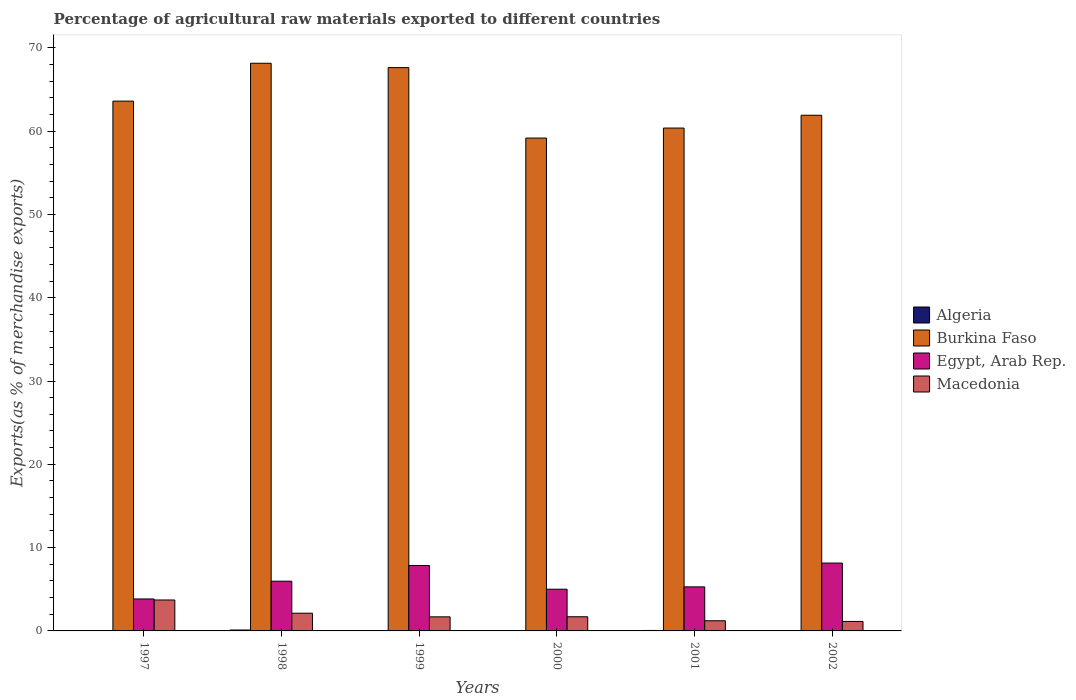How many different coloured bars are there?
Ensure brevity in your answer.  4. Are the number of bars per tick equal to the number of legend labels?
Provide a short and direct response. Yes. Are the number of bars on each tick of the X-axis equal?
Provide a short and direct response. Yes. How many bars are there on the 4th tick from the left?
Your answer should be compact. 4. How many bars are there on the 3rd tick from the right?
Make the answer very short. 4. What is the label of the 5th group of bars from the left?
Offer a very short reply. 2001. What is the percentage of exports to different countries in Macedonia in 2002?
Ensure brevity in your answer.  1.14. Across all years, what is the maximum percentage of exports to different countries in Burkina Faso?
Your answer should be very brief. 68.14. Across all years, what is the minimum percentage of exports to different countries in Macedonia?
Your answer should be compact. 1.14. In which year was the percentage of exports to different countries in Egypt, Arab Rep. maximum?
Your response must be concise. 2002. What is the total percentage of exports to different countries in Burkina Faso in the graph?
Give a very brief answer. 380.79. What is the difference between the percentage of exports to different countries in Egypt, Arab Rep. in 1998 and that in 2001?
Give a very brief answer. 0.68. What is the difference between the percentage of exports to different countries in Egypt, Arab Rep. in 2000 and the percentage of exports to different countries in Macedonia in 1997?
Give a very brief answer. 1.29. What is the average percentage of exports to different countries in Burkina Faso per year?
Offer a very short reply. 63.47. In the year 1999, what is the difference between the percentage of exports to different countries in Macedonia and percentage of exports to different countries in Burkina Faso?
Keep it short and to the point. -65.93. What is the ratio of the percentage of exports to different countries in Algeria in 1997 to that in 2002?
Make the answer very short. 3.18. What is the difference between the highest and the second highest percentage of exports to different countries in Burkina Faso?
Your answer should be very brief. 0.52. What is the difference between the highest and the lowest percentage of exports to different countries in Macedonia?
Ensure brevity in your answer.  2.58. Is it the case that in every year, the sum of the percentage of exports to different countries in Egypt, Arab Rep. and percentage of exports to different countries in Macedonia is greater than the sum of percentage of exports to different countries in Burkina Faso and percentage of exports to different countries in Algeria?
Offer a terse response. No. What does the 3rd bar from the left in 2001 represents?
Give a very brief answer. Egypt, Arab Rep. What does the 3rd bar from the right in 1998 represents?
Your answer should be compact. Burkina Faso. How many bars are there?
Make the answer very short. 24. Are all the bars in the graph horizontal?
Offer a terse response. No. What is the difference between two consecutive major ticks on the Y-axis?
Provide a succinct answer. 10. Does the graph contain grids?
Make the answer very short. No. How many legend labels are there?
Your response must be concise. 4. How are the legend labels stacked?
Give a very brief answer. Vertical. What is the title of the graph?
Provide a succinct answer. Percentage of agricultural raw materials exported to different countries. Does "Jamaica" appear as one of the legend labels in the graph?
Offer a very short reply. No. What is the label or title of the Y-axis?
Make the answer very short. Exports(as % of merchandise exports). What is the Exports(as % of merchandise exports) of Algeria in 1997?
Ensure brevity in your answer.  0.05. What is the Exports(as % of merchandise exports) of Burkina Faso in 1997?
Your answer should be compact. 63.6. What is the Exports(as % of merchandise exports) in Egypt, Arab Rep. in 1997?
Your response must be concise. 3.84. What is the Exports(as % of merchandise exports) in Macedonia in 1997?
Make the answer very short. 3.71. What is the Exports(as % of merchandise exports) of Algeria in 1998?
Your answer should be compact. 0.11. What is the Exports(as % of merchandise exports) in Burkina Faso in 1998?
Offer a terse response. 68.14. What is the Exports(as % of merchandise exports) of Egypt, Arab Rep. in 1998?
Make the answer very short. 5.97. What is the Exports(as % of merchandise exports) of Macedonia in 1998?
Keep it short and to the point. 2.13. What is the Exports(as % of merchandise exports) of Algeria in 1999?
Keep it short and to the point. 0.04. What is the Exports(as % of merchandise exports) in Burkina Faso in 1999?
Offer a terse response. 67.62. What is the Exports(as % of merchandise exports) of Egypt, Arab Rep. in 1999?
Your answer should be compact. 7.85. What is the Exports(as % of merchandise exports) of Macedonia in 1999?
Your answer should be compact. 1.69. What is the Exports(as % of merchandise exports) in Algeria in 2000?
Ensure brevity in your answer.  0.05. What is the Exports(as % of merchandise exports) in Burkina Faso in 2000?
Your answer should be compact. 59.16. What is the Exports(as % of merchandise exports) in Egypt, Arab Rep. in 2000?
Your answer should be compact. 5.01. What is the Exports(as % of merchandise exports) in Macedonia in 2000?
Make the answer very short. 1.7. What is the Exports(as % of merchandise exports) in Algeria in 2001?
Your answer should be very brief. 0.05. What is the Exports(as % of merchandise exports) of Burkina Faso in 2001?
Give a very brief answer. 60.36. What is the Exports(as % of merchandise exports) of Egypt, Arab Rep. in 2001?
Ensure brevity in your answer.  5.29. What is the Exports(as % of merchandise exports) in Macedonia in 2001?
Provide a short and direct response. 1.22. What is the Exports(as % of merchandise exports) in Algeria in 2002?
Your response must be concise. 0.02. What is the Exports(as % of merchandise exports) in Burkina Faso in 2002?
Keep it short and to the point. 61.9. What is the Exports(as % of merchandise exports) of Egypt, Arab Rep. in 2002?
Provide a short and direct response. 8.15. What is the Exports(as % of merchandise exports) in Macedonia in 2002?
Give a very brief answer. 1.14. Across all years, what is the maximum Exports(as % of merchandise exports) of Algeria?
Your answer should be very brief. 0.11. Across all years, what is the maximum Exports(as % of merchandise exports) of Burkina Faso?
Provide a succinct answer. 68.14. Across all years, what is the maximum Exports(as % of merchandise exports) of Egypt, Arab Rep.?
Your answer should be compact. 8.15. Across all years, what is the maximum Exports(as % of merchandise exports) of Macedonia?
Offer a very short reply. 3.71. Across all years, what is the minimum Exports(as % of merchandise exports) in Algeria?
Your response must be concise. 0.02. Across all years, what is the minimum Exports(as % of merchandise exports) of Burkina Faso?
Your response must be concise. 59.16. Across all years, what is the minimum Exports(as % of merchandise exports) of Egypt, Arab Rep.?
Keep it short and to the point. 3.84. Across all years, what is the minimum Exports(as % of merchandise exports) of Macedonia?
Give a very brief answer. 1.14. What is the total Exports(as % of merchandise exports) in Algeria in the graph?
Keep it short and to the point. 0.32. What is the total Exports(as % of merchandise exports) in Burkina Faso in the graph?
Your answer should be compact. 380.79. What is the total Exports(as % of merchandise exports) in Egypt, Arab Rep. in the graph?
Your answer should be compact. 36.1. What is the total Exports(as % of merchandise exports) of Macedonia in the graph?
Your answer should be compact. 11.59. What is the difference between the Exports(as % of merchandise exports) of Algeria in 1997 and that in 1998?
Keep it short and to the point. -0.06. What is the difference between the Exports(as % of merchandise exports) in Burkina Faso in 1997 and that in 1998?
Ensure brevity in your answer.  -4.54. What is the difference between the Exports(as % of merchandise exports) in Egypt, Arab Rep. in 1997 and that in 1998?
Offer a very short reply. -2.13. What is the difference between the Exports(as % of merchandise exports) of Macedonia in 1997 and that in 1998?
Provide a succinct answer. 1.59. What is the difference between the Exports(as % of merchandise exports) in Algeria in 1997 and that in 1999?
Keep it short and to the point. 0.01. What is the difference between the Exports(as % of merchandise exports) of Burkina Faso in 1997 and that in 1999?
Your response must be concise. -4.02. What is the difference between the Exports(as % of merchandise exports) in Egypt, Arab Rep. in 1997 and that in 1999?
Make the answer very short. -4.02. What is the difference between the Exports(as % of merchandise exports) of Macedonia in 1997 and that in 1999?
Provide a short and direct response. 2.02. What is the difference between the Exports(as % of merchandise exports) of Algeria in 1997 and that in 2000?
Make the answer very short. -0. What is the difference between the Exports(as % of merchandise exports) in Burkina Faso in 1997 and that in 2000?
Your answer should be compact. 4.44. What is the difference between the Exports(as % of merchandise exports) in Egypt, Arab Rep. in 1997 and that in 2000?
Ensure brevity in your answer.  -1.17. What is the difference between the Exports(as % of merchandise exports) of Macedonia in 1997 and that in 2000?
Provide a succinct answer. 2.01. What is the difference between the Exports(as % of merchandise exports) of Algeria in 1997 and that in 2001?
Provide a succinct answer. -0.01. What is the difference between the Exports(as % of merchandise exports) in Burkina Faso in 1997 and that in 2001?
Keep it short and to the point. 3.23. What is the difference between the Exports(as % of merchandise exports) in Egypt, Arab Rep. in 1997 and that in 2001?
Give a very brief answer. -1.45. What is the difference between the Exports(as % of merchandise exports) in Macedonia in 1997 and that in 2001?
Provide a succinct answer. 2.49. What is the difference between the Exports(as % of merchandise exports) in Algeria in 1997 and that in 2002?
Give a very brief answer. 0.03. What is the difference between the Exports(as % of merchandise exports) in Burkina Faso in 1997 and that in 2002?
Make the answer very short. 1.7. What is the difference between the Exports(as % of merchandise exports) of Egypt, Arab Rep. in 1997 and that in 2002?
Keep it short and to the point. -4.31. What is the difference between the Exports(as % of merchandise exports) in Macedonia in 1997 and that in 2002?
Give a very brief answer. 2.58. What is the difference between the Exports(as % of merchandise exports) of Algeria in 1998 and that in 1999?
Offer a terse response. 0.07. What is the difference between the Exports(as % of merchandise exports) in Burkina Faso in 1998 and that in 1999?
Your answer should be compact. 0.52. What is the difference between the Exports(as % of merchandise exports) in Egypt, Arab Rep. in 1998 and that in 1999?
Your answer should be very brief. -1.88. What is the difference between the Exports(as % of merchandise exports) in Macedonia in 1998 and that in 1999?
Give a very brief answer. 0.44. What is the difference between the Exports(as % of merchandise exports) of Algeria in 1998 and that in 2000?
Provide a succinct answer. 0.06. What is the difference between the Exports(as % of merchandise exports) of Burkina Faso in 1998 and that in 2000?
Give a very brief answer. 8.98. What is the difference between the Exports(as % of merchandise exports) in Egypt, Arab Rep. in 1998 and that in 2000?
Provide a short and direct response. 0.96. What is the difference between the Exports(as % of merchandise exports) of Macedonia in 1998 and that in 2000?
Give a very brief answer. 0.43. What is the difference between the Exports(as % of merchandise exports) of Algeria in 1998 and that in 2001?
Your answer should be very brief. 0.05. What is the difference between the Exports(as % of merchandise exports) of Burkina Faso in 1998 and that in 2001?
Your response must be concise. 7.78. What is the difference between the Exports(as % of merchandise exports) in Egypt, Arab Rep. in 1998 and that in 2001?
Make the answer very short. 0.68. What is the difference between the Exports(as % of merchandise exports) in Macedonia in 1998 and that in 2001?
Your answer should be compact. 0.91. What is the difference between the Exports(as % of merchandise exports) in Algeria in 1998 and that in 2002?
Provide a succinct answer. 0.09. What is the difference between the Exports(as % of merchandise exports) of Burkina Faso in 1998 and that in 2002?
Provide a succinct answer. 6.24. What is the difference between the Exports(as % of merchandise exports) in Egypt, Arab Rep. in 1998 and that in 2002?
Your response must be concise. -2.18. What is the difference between the Exports(as % of merchandise exports) in Algeria in 1999 and that in 2000?
Make the answer very short. -0.01. What is the difference between the Exports(as % of merchandise exports) of Burkina Faso in 1999 and that in 2000?
Your response must be concise. 8.46. What is the difference between the Exports(as % of merchandise exports) of Egypt, Arab Rep. in 1999 and that in 2000?
Provide a short and direct response. 2.85. What is the difference between the Exports(as % of merchandise exports) in Macedonia in 1999 and that in 2000?
Give a very brief answer. -0.01. What is the difference between the Exports(as % of merchandise exports) of Algeria in 1999 and that in 2001?
Make the answer very short. -0.02. What is the difference between the Exports(as % of merchandise exports) of Burkina Faso in 1999 and that in 2001?
Provide a succinct answer. 7.26. What is the difference between the Exports(as % of merchandise exports) in Egypt, Arab Rep. in 1999 and that in 2001?
Keep it short and to the point. 2.57. What is the difference between the Exports(as % of merchandise exports) in Macedonia in 1999 and that in 2001?
Your response must be concise. 0.47. What is the difference between the Exports(as % of merchandise exports) in Algeria in 1999 and that in 2002?
Give a very brief answer. 0.02. What is the difference between the Exports(as % of merchandise exports) in Burkina Faso in 1999 and that in 2002?
Make the answer very short. 5.72. What is the difference between the Exports(as % of merchandise exports) of Egypt, Arab Rep. in 1999 and that in 2002?
Your answer should be compact. -0.29. What is the difference between the Exports(as % of merchandise exports) of Macedonia in 1999 and that in 2002?
Your answer should be very brief. 0.55. What is the difference between the Exports(as % of merchandise exports) of Algeria in 2000 and that in 2001?
Keep it short and to the point. -0.01. What is the difference between the Exports(as % of merchandise exports) in Burkina Faso in 2000 and that in 2001?
Provide a succinct answer. -1.2. What is the difference between the Exports(as % of merchandise exports) in Egypt, Arab Rep. in 2000 and that in 2001?
Your answer should be compact. -0.28. What is the difference between the Exports(as % of merchandise exports) in Macedonia in 2000 and that in 2001?
Offer a very short reply. 0.48. What is the difference between the Exports(as % of merchandise exports) in Algeria in 2000 and that in 2002?
Make the answer very short. 0.03. What is the difference between the Exports(as % of merchandise exports) of Burkina Faso in 2000 and that in 2002?
Offer a very short reply. -2.74. What is the difference between the Exports(as % of merchandise exports) of Egypt, Arab Rep. in 2000 and that in 2002?
Provide a short and direct response. -3.14. What is the difference between the Exports(as % of merchandise exports) in Macedonia in 2000 and that in 2002?
Your response must be concise. 0.56. What is the difference between the Exports(as % of merchandise exports) in Algeria in 2001 and that in 2002?
Make the answer very short. 0.04. What is the difference between the Exports(as % of merchandise exports) of Burkina Faso in 2001 and that in 2002?
Ensure brevity in your answer.  -1.54. What is the difference between the Exports(as % of merchandise exports) in Egypt, Arab Rep. in 2001 and that in 2002?
Ensure brevity in your answer.  -2.86. What is the difference between the Exports(as % of merchandise exports) of Macedonia in 2001 and that in 2002?
Provide a short and direct response. 0.08. What is the difference between the Exports(as % of merchandise exports) of Algeria in 1997 and the Exports(as % of merchandise exports) of Burkina Faso in 1998?
Offer a terse response. -68.09. What is the difference between the Exports(as % of merchandise exports) in Algeria in 1997 and the Exports(as % of merchandise exports) in Egypt, Arab Rep. in 1998?
Your answer should be compact. -5.92. What is the difference between the Exports(as % of merchandise exports) of Algeria in 1997 and the Exports(as % of merchandise exports) of Macedonia in 1998?
Keep it short and to the point. -2.08. What is the difference between the Exports(as % of merchandise exports) of Burkina Faso in 1997 and the Exports(as % of merchandise exports) of Egypt, Arab Rep. in 1998?
Your answer should be compact. 57.63. What is the difference between the Exports(as % of merchandise exports) in Burkina Faso in 1997 and the Exports(as % of merchandise exports) in Macedonia in 1998?
Your answer should be compact. 61.47. What is the difference between the Exports(as % of merchandise exports) in Egypt, Arab Rep. in 1997 and the Exports(as % of merchandise exports) in Macedonia in 1998?
Offer a very short reply. 1.71. What is the difference between the Exports(as % of merchandise exports) of Algeria in 1997 and the Exports(as % of merchandise exports) of Burkina Faso in 1999?
Offer a very short reply. -67.57. What is the difference between the Exports(as % of merchandise exports) in Algeria in 1997 and the Exports(as % of merchandise exports) in Egypt, Arab Rep. in 1999?
Offer a terse response. -7.8. What is the difference between the Exports(as % of merchandise exports) of Algeria in 1997 and the Exports(as % of merchandise exports) of Macedonia in 1999?
Your answer should be compact. -1.64. What is the difference between the Exports(as % of merchandise exports) in Burkina Faso in 1997 and the Exports(as % of merchandise exports) in Egypt, Arab Rep. in 1999?
Ensure brevity in your answer.  55.74. What is the difference between the Exports(as % of merchandise exports) of Burkina Faso in 1997 and the Exports(as % of merchandise exports) of Macedonia in 1999?
Make the answer very short. 61.91. What is the difference between the Exports(as % of merchandise exports) in Egypt, Arab Rep. in 1997 and the Exports(as % of merchandise exports) in Macedonia in 1999?
Your answer should be compact. 2.15. What is the difference between the Exports(as % of merchandise exports) of Algeria in 1997 and the Exports(as % of merchandise exports) of Burkina Faso in 2000?
Your answer should be compact. -59.11. What is the difference between the Exports(as % of merchandise exports) in Algeria in 1997 and the Exports(as % of merchandise exports) in Egypt, Arab Rep. in 2000?
Keep it short and to the point. -4.96. What is the difference between the Exports(as % of merchandise exports) of Algeria in 1997 and the Exports(as % of merchandise exports) of Macedonia in 2000?
Your response must be concise. -1.65. What is the difference between the Exports(as % of merchandise exports) in Burkina Faso in 1997 and the Exports(as % of merchandise exports) in Egypt, Arab Rep. in 2000?
Offer a terse response. 58.59. What is the difference between the Exports(as % of merchandise exports) in Burkina Faso in 1997 and the Exports(as % of merchandise exports) in Macedonia in 2000?
Provide a short and direct response. 61.9. What is the difference between the Exports(as % of merchandise exports) of Egypt, Arab Rep. in 1997 and the Exports(as % of merchandise exports) of Macedonia in 2000?
Make the answer very short. 2.14. What is the difference between the Exports(as % of merchandise exports) in Algeria in 1997 and the Exports(as % of merchandise exports) in Burkina Faso in 2001?
Ensure brevity in your answer.  -60.31. What is the difference between the Exports(as % of merchandise exports) of Algeria in 1997 and the Exports(as % of merchandise exports) of Egypt, Arab Rep. in 2001?
Offer a terse response. -5.24. What is the difference between the Exports(as % of merchandise exports) in Algeria in 1997 and the Exports(as % of merchandise exports) in Macedonia in 2001?
Provide a short and direct response. -1.17. What is the difference between the Exports(as % of merchandise exports) of Burkina Faso in 1997 and the Exports(as % of merchandise exports) of Egypt, Arab Rep. in 2001?
Ensure brevity in your answer.  58.31. What is the difference between the Exports(as % of merchandise exports) of Burkina Faso in 1997 and the Exports(as % of merchandise exports) of Macedonia in 2001?
Your response must be concise. 62.38. What is the difference between the Exports(as % of merchandise exports) in Egypt, Arab Rep. in 1997 and the Exports(as % of merchandise exports) in Macedonia in 2001?
Offer a very short reply. 2.62. What is the difference between the Exports(as % of merchandise exports) in Algeria in 1997 and the Exports(as % of merchandise exports) in Burkina Faso in 2002?
Offer a terse response. -61.85. What is the difference between the Exports(as % of merchandise exports) of Algeria in 1997 and the Exports(as % of merchandise exports) of Egypt, Arab Rep. in 2002?
Give a very brief answer. -8.1. What is the difference between the Exports(as % of merchandise exports) in Algeria in 1997 and the Exports(as % of merchandise exports) in Macedonia in 2002?
Your response must be concise. -1.09. What is the difference between the Exports(as % of merchandise exports) of Burkina Faso in 1997 and the Exports(as % of merchandise exports) of Egypt, Arab Rep. in 2002?
Provide a succinct answer. 55.45. What is the difference between the Exports(as % of merchandise exports) in Burkina Faso in 1997 and the Exports(as % of merchandise exports) in Macedonia in 2002?
Your response must be concise. 62.46. What is the difference between the Exports(as % of merchandise exports) in Egypt, Arab Rep. in 1997 and the Exports(as % of merchandise exports) in Macedonia in 2002?
Give a very brief answer. 2.7. What is the difference between the Exports(as % of merchandise exports) in Algeria in 1998 and the Exports(as % of merchandise exports) in Burkina Faso in 1999?
Keep it short and to the point. -67.51. What is the difference between the Exports(as % of merchandise exports) of Algeria in 1998 and the Exports(as % of merchandise exports) of Egypt, Arab Rep. in 1999?
Your response must be concise. -7.74. What is the difference between the Exports(as % of merchandise exports) of Algeria in 1998 and the Exports(as % of merchandise exports) of Macedonia in 1999?
Provide a short and direct response. -1.58. What is the difference between the Exports(as % of merchandise exports) in Burkina Faso in 1998 and the Exports(as % of merchandise exports) in Egypt, Arab Rep. in 1999?
Ensure brevity in your answer.  60.29. What is the difference between the Exports(as % of merchandise exports) of Burkina Faso in 1998 and the Exports(as % of merchandise exports) of Macedonia in 1999?
Offer a terse response. 66.45. What is the difference between the Exports(as % of merchandise exports) of Egypt, Arab Rep. in 1998 and the Exports(as % of merchandise exports) of Macedonia in 1999?
Provide a short and direct response. 4.28. What is the difference between the Exports(as % of merchandise exports) in Algeria in 1998 and the Exports(as % of merchandise exports) in Burkina Faso in 2000?
Give a very brief answer. -59.05. What is the difference between the Exports(as % of merchandise exports) of Algeria in 1998 and the Exports(as % of merchandise exports) of Egypt, Arab Rep. in 2000?
Your response must be concise. -4.9. What is the difference between the Exports(as % of merchandise exports) in Algeria in 1998 and the Exports(as % of merchandise exports) in Macedonia in 2000?
Offer a very short reply. -1.59. What is the difference between the Exports(as % of merchandise exports) in Burkina Faso in 1998 and the Exports(as % of merchandise exports) in Egypt, Arab Rep. in 2000?
Make the answer very short. 63.14. What is the difference between the Exports(as % of merchandise exports) of Burkina Faso in 1998 and the Exports(as % of merchandise exports) of Macedonia in 2000?
Ensure brevity in your answer.  66.44. What is the difference between the Exports(as % of merchandise exports) in Egypt, Arab Rep. in 1998 and the Exports(as % of merchandise exports) in Macedonia in 2000?
Make the answer very short. 4.27. What is the difference between the Exports(as % of merchandise exports) of Algeria in 1998 and the Exports(as % of merchandise exports) of Burkina Faso in 2001?
Your answer should be very brief. -60.26. What is the difference between the Exports(as % of merchandise exports) in Algeria in 1998 and the Exports(as % of merchandise exports) in Egypt, Arab Rep. in 2001?
Provide a succinct answer. -5.18. What is the difference between the Exports(as % of merchandise exports) in Algeria in 1998 and the Exports(as % of merchandise exports) in Macedonia in 2001?
Make the answer very short. -1.11. What is the difference between the Exports(as % of merchandise exports) of Burkina Faso in 1998 and the Exports(as % of merchandise exports) of Egypt, Arab Rep. in 2001?
Offer a terse response. 62.85. What is the difference between the Exports(as % of merchandise exports) in Burkina Faso in 1998 and the Exports(as % of merchandise exports) in Macedonia in 2001?
Offer a very short reply. 66.92. What is the difference between the Exports(as % of merchandise exports) in Egypt, Arab Rep. in 1998 and the Exports(as % of merchandise exports) in Macedonia in 2001?
Your response must be concise. 4.75. What is the difference between the Exports(as % of merchandise exports) of Algeria in 1998 and the Exports(as % of merchandise exports) of Burkina Faso in 2002?
Provide a succinct answer. -61.79. What is the difference between the Exports(as % of merchandise exports) of Algeria in 1998 and the Exports(as % of merchandise exports) of Egypt, Arab Rep. in 2002?
Your answer should be very brief. -8.04. What is the difference between the Exports(as % of merchandise exports) in Algeria in 1998 and the Exports(as % of merchandise exports) in Macedonia in 2002?
Make the answer very short. -1.03. What is the difference between the Exports(as % of merchandise exports) in Burkina Faso in 1998 and the Exports(as % of merchandise exports) in Egypt, Arab Rep. in 2002?
Ensure brevity in your answer.  60. What is the difference between the Exports(as % of merchandise exports) of Burkina Faso in 1998 and the Exports(as % of merchandise exports) of Macedonia in 2002?
Ensure brevity in your answer.  67.01. What is the difference between the Exports(as % of merchandise exports) of Egypt, Arab Rep. in 1998 and the Exports(as % of merchandise exports) of Macedonia in 2002?
Your response must be concise. 4.83. What is the difference between the Exports(as % of merchandise exports) in Algeria in 1999 and the Exports(as % of merchandise exports) in Burkina Faso in 2000?
Your answer should be compact. -59.12. What is the difference between the Exports(as % of merchandise exports) of Algeria in 1999 and the Exports(as % of merchandise exports) of Egypt, Arab Rep. in 2000?
Your response must be concise. -4.97. What is the difference between the Exports(as % of merchandise exports) of Algeria in 1999 and the Exports(as % of merchandise exports) of Macedonia in 2000?
Give a very brief answer. -1.66. What is the difference between the Exports(as % of merchandise exports) in Burkina Faso in 1999 and the Exports(as % of merchandise exports) in Egypt, Arab Rep. in 2000?
Offer a terse response. 62.61. What is the difference between the Exports(as % of merchandise exports) in Burkina Faso in 1999 and the Exports(as % of merchandise exports) in Macedonia in 2000?
Your answer should be very brief. 65.92. What is the difference between the Exports(as % of merchandise exports) in Egypt, Arab Rep. in 1999 and the Exports(as % of merchandise exports) in Macedonia in 2000?
Give a very brief answer. 6.15. What is the difference between the Exports(as % of merchandise exports) of Algeria in 1999 and the Exports(as % of merchandise exports) of Burkina Faso in 2001?
Provide a succinct answer. -60.33. What is the difference between the Exports(as % of merchandise exports) of Algeria in 1999 and the Exports(as % of merchandise exports) of Egypt, Arab Rep. in 2001?
Your answer should be very brief. -5.25. What is the difference between the Exports(as % of merchandise exports) in Algeria in 1999 and the Exports(as % of merchandise exports) in Macedonia in 2001?
Provide a succinct answer. -1.18. What is the difference between the Exports(as % of merchandise exports) of Burkina Faso in 1999 and the Exports(as % of merchandise exports) of Egypt, Arab Rep. in 2001?
Keep it short and to the point. 62.33. What is the difference between the Exports(as % of merchandise exports) of Burkina Faso in 1999 and the Exports(as % of merchandise exports) of Macedonia in 2001?
Offer a very short reply. 66.4. What is the difference between the Exports(as % of merchandise exports) in Egypt, Arab Rep. in 1999 and the Exports(as % of merchandise exports) in Macedonia in 2001?
Keep it short and to the point. 6.63. What is the difference between the Exports(as % of merchandise exports) in Algeria in 1999 and the Exports(as % of merchandise exports) in Burkina Faso in 2002?
Provide a short and direct response. -61.86. What is the difference between the Exports(as % of merchandise exports) of Algeria in 1999 and the Exports(as % of merchandise exports) of Egypt, Arab Rep. in 2002?
Keep it short and to the point. -8.11. What is the difference between the Exports(as % of merchandise exports) in Algeria in 1999 and the Exports(as % of merchandise exports) in Macedonia in 2002?
Provide a succinct answer. -1.1. What is the difference between the Exports(as % of merchandise exports) of Burkina Faso in 1999 and the Exports(as % of merchandise exports) of Egypt, Arab Rep. in 2002?
Keep it short and to the point. 59.47. What is the difference between the Exports(as % of merchandise exports) of Burkina Faso in 1999 and the Exports(as % of merchandise exports) of Macedonia in 2002?
Give a very brief answer. 66.48. What is the difference between the Exports(as % of merchandise exports) of Egypt, Arab Rep. in 1999 and the Exports(as % of merchandise exports) of Macedonia in 2002?
Provide a short and direct response. 6.72. What is the difference between the Exports(as % of merchandise exports) of Algeria in 2000 and the Exports(as % of merchandise exports) of Burkina Faso in 2001?
Offer a very short reply. -60.31. What is the difference between the Exports(as % of merchandise exports) in Algeria in 2000 and the Exports(as % of merchandise exports) in Egypt, Arab Rep. in 2001?
Provide a short and direct response. -5.24. What is the difference between the Exports(as % of merchandise exports) in Algeria in 2000 and the Exports(as % of merchandise exports) in Macedonia in 2001?
Provide a succinct answer. -1.17. What is the difference between the Exports(as % of merchandise exports) of Burkina Faso in 2000 and the Exports(as % of merchandise exports) of Egypt, Arab Rep. in 2001?
Your answer should be compact. 53.88. What is the difference between the Exports(as % of merchandise exports) in Burkina Faso in 2000 and the Exports(as % of merchandise exports) in Macedonia in 2001?
Offer a very short reply. 57.94. What is the difference between the Exports(as % of merchandise exports) in Egypt, Arab Rep. in 2000 and the Exports(as % of merchandise exports) in Macedonia in 2001?
Give a very brief answer. 3.79. What is the difference between the Exports(as % of merchandise exports) of Algeria in 2000 and the Exports(as % of merchandise exports) of Burkina Faso in 2002?
Give a very brief answer. -61.85. What is the difference between the Exports(as % of merchandise exports) of Algeria in 2000 and the Exports(as % of merchandise exports) of Egypt, Arab Rep. in 2002?
Offer a terse response. -8.1. What is the difference between the Exports(as % of merchandise exports) of Algeria in 2000 and the Exports(as % of merchandise exports) of Macedonia in 2002?
Provide a succinct answer. -1.09. What is the difference between the Exports(as % of merchandise exports) of Burkina Faso in 2000 and the Exports(as % of merchandise exports) of Egypt, Arab Rep. in 2002?
Provide a succinct answer. 51.02. What is the difference between the Exports(as % of merchandise exports) in Burkina Faso in 2000 and the Exports(as % of merchandise exports) in Macedonia in 2002?
Your answer should be compact. 58.03. What is the difference between the Exports(as % of merchandise exports) in Egypt, Arab Rep. in 2000 and the Exports(as % of merchandise exports) in Macedonia in 2002?
Give a very brief answer. 3.87. What is the difference between the Exports(as % of merchandise exports) in Algeria in 2001 and the Exports(as % of merchandise exports) in Burkina Faso in 2002?
Give a very brief answer. -61.85. What is the difference between the Exports(as % of merchandise exports) in Algeria in 2001 and the Exports(as % of merchandise exports) in Egypt, Arab Rep. in 2002?
Offer a terse response. -8.09. What is the difference between the Exports(as % of merchandise exports) of Algeria in 2001 and the Exports(as % of merchandise exports) of Macedonia in 2002?
Your answer should be compact. -1.08. What is the difference between the Exports(as % of merchandise exports) in Burkina Faso in 2001 and the Exports(as % of merchandise exports) in Egypt, Arab Rep. in 2002?
Your response must be concise. 52.22. What is the difference between the Exports(as % of merchandise exports) in Burkina Faso in 2001 and the Exports(as % of merchandise exports) in Macedonia in 2002?
Your answer should be very brief. 59.23. What is the difference between the Exports(as % of merchandise exports) in Egypt, Arab Rep. in 2001 and the Exports(as % of merchandise exports) in Macedonia in 2002?
Your answer should be very brief. 4.15. What is the average Exports(as % of merchandise exports) of Algeria per year?
Make the answer very short. 0.05. What is the average Exports(as % of merchandise exports) of Burkina Faso per year?
Your answer should be compact. 63.47. What is the average Exports(as % of merchandise exports) of Egypt, Arab Rep. per year?
Give a very brief answer. 6.02. What is the average Exports(as % of merchandise exports) in Macedonia per year?
Offer a very short reply. 1.93. In the year 1997, what is the difference between the Exports(as % of merchandise exports) of Algeria and Exports(as % of merchandise exports) of Burkina Faso?
Your answer should be very brief. -63.55. In the year 1997, what is the difference between the Exports(as % of merchandise exports) in Algeria and Exports(as % of merchandise exports) in Egypt, Arab Rep.?
Offer a terse response. -3.79. In the year 1997, what is the difference between the Exports(as % of merchandise exports) of Algeria and Exports(as % of merchandise exports) of Macedonia?
Make the answer very short. -3.66. In the year 1997, what is the difference between the Exports(as % of merchandise exports) in Burkina Faso and Exports(as % of merchandise exports) in Egypt, Arab Rep.?
Offer a terse response. 59.76. In the year 1997, what is the difference between the Exports(as % of merchandise exports) of Burkina Faso and Exports(as % of merchandise exports) of Macedonia?
Make the answer very short. 59.88. In the year 1997, what is the difference between the Exports(as % of merchandise exports) in Egypt, Arab Rep. and Exports(as % of merchandise exports) in Macedonia?
Your response must be concise. 0.12. In the year 1998, what is the difference between the Exports(as % of merchandise exports) of Algeria and Exports(as % of merchandise exports) of Burkina Faso?
Give a very brief answer. -68.03. In the year 1998, what is the difference between the Exports(as % of merchandise exports) of Algeria and Exports(as % of merchandise exports) of Egypt, Arab Rep.?
Your answer should be compact. -5.86. In the year 1998, what is the difference between the Exports(as % of merchandise exports) of Algeria and Exports(as % of merchandise exports) of Macedonia?
Give a very brief answer. -2.02. In the year 1998, what is the difference between the Exports(as % of merchandise exports) of Burkina Faso and Exports(as % of merchandise exports) of Egypt, Arab Rep.?
Keep it short and to the point. 62.17. In the year 1998, what is the difference between the Exports(as % of merchandise exports) of Burkina Faso and Exports(as % of merchandise exports) of Macedonia?
Keep it short and to the point. 66.02. In the year 1998, what is the difference between the Exports(as % of merchandise exports) in Egypt, Arab Rep. and Exports(as % of merchandise exports) in Macedonia?
Your response must be concise. 3.84. In the year 1999, what is the difference between the Exports(as % of merchandise exports) of Algeria and Exports(as % of merchandise exports) of Burkina Faso?
Give a very brief answer. -67.58. In the year 1999, what is the difference between the Exports(as % of merchandise exports) in Algeria and Exports(as % of merchandise exports) in Egypt, Arab Rep.?
Provide a succinct answer. -7.82. In the year 1999, what is the difference between the Exports(as % of merchandise exports) in Algeria and Exports(as % of merchandise exports) in Macedonia?
Make the answer very short. -1.65. In the year 1999, what is the difference between the Exports(as % of merchandise exports) in Burkina Faso and Exports(as % of merchandise exports) in Egypt, Arab Rep.?
Offer a terse response. 59.77. In the year 1999, what is the difference between the Exports(as % of merchandise exports) in Burkina Faso and Exports(as % of merchandise exports) in Macedonia?
Provide a short and direct response. 65.93. In the year 1999, what is the difference between the Exports(as % of merchandise exports) of Egypt, Arab Rep. and Exports(as % of merchandise exports) of Macedonia?
Keep it short and to the point. 6.16. In the year 2000, what is the difference between the Exports(as % of merchandise exports) of Algeria and Exports(as % of merchandise exports) of Burkina Faso?
Make the answer very short. -59.11. In the year 2000, what is the difference between the Exports(as % of merchandise exports) in Algeria and Exports(as % of merchandise exports) in Egypt, Arab Rep.?
Your answer should be compact. -4.96. In the year 2000, what is the difference between the Exports(as % of merchandise exports) of Algeria and Exports(as % of merchandise exports) of Macedonia?
Ensure brevity in your answer.  -1.65. In the year 2000, what is the difference between the Exports(as % of merchandise exports) of Burkina Faso and Exports(as % of merchandise exports) of Egypt, Arab Rep.?
Keep it short and to the point. 54.16. In the year 2000, what is the difference between the Exports(as % of merchandise exports) of Burkina Faso and Exports(as % of merchandise exports) of Macedonia?
Keep it short and to the point. 57.46. In the year 2000, what is the difference between the Exports(as % of merchandise exports) of Egypt, Arab Rep. and Exports(as % of merchandise exports) of Macedonia?
Provide a short and direct response. 3.31. In the year 2001, what is the difference between the Exports(as % of merchandise exports) of Algeria and Exports(as % of merchandise exports) of Burkina Faso?
Your answer should be very brief. -60.31. In the year 2001, what is the difference between the Exports(as % of merchandise exports) of Algeria and Exports(as % of merchandise exports) of Egypt, Arab Rep.?
Provide a succinct answer. -5.23. In the year 2001, what is the difference between the Exports(as % of merchandise exports) of Algeria and Exports(as % of merchandise exports) of Macedonia?
Ensure brevity in your answer.  -1.17. In the year 2001, what is the difference between the Exports(as % of merchandise exports) of Burkina Faso and Exports(as % of merchandise exports) of Egypt, Arab Rep.?
Give a very brief answer. 55.08. In the year 2001, what is the difference between the Exports(as % of merchandise exports) of Burkina Faso and Exports(as % of merchandise exports) of Macedonia?
Provide a succinct answer. 59.14. In the year 2001, what is the difference between the Exports(as % of merchandise exports) of Egypt, Arab Rep. and Exports(as % of merchandise exports) of Macedonia?
Your response must be concise. 4.07. In the year 2002, what is the difference between the Exports(as % of merchandise exports) in Algeria and Exports(as % of merchandise exports) in Burkina Faso?
Your response must be concise. -61.89. In the year 2002, what is the difference between the Exports(as % of merchandise exports) in Algeria and Exports(as % of merchandise exports) in Egypt, Arab Rep.?
Offer a terse response. -8.13. In the year 2002, what is the difference between the Exports(as % of merchandise exports) of Algeria and Exports(as % of merchandise exports) of Macedonia?
Ensure brevity in your answer.  -1.12. In the year 2002, what is the difference between the Exports(as % of merchandise exports) of Burkina Faso and Exports(as % of merchandise exports) of Egypt, Arab Rep.?
Ensure brevity in your answer.  53.76. In the year 2002, what is the difference between the Exports(as % of merchandise exports) in Burkina Faso and Exports(as % of merchandise exports) in Macedonia?
Your response must be concise. 60.77. In the year 2002, what is the difference between the Exports(as % of merchandise exports) in Egypt, Arab Rep. and Exports(as % of merchandise exports) in Macedonia?
Your answer should be compact. 7.01. What is the ratio of the Exports(as % of merchandise exports) of Algeria in 1997 to that in 1998?
Keep it short and to the point. 0.45. What is the ratio of the Exports(as % of merchandise exports) in Egypt, Arab Rep. in 1997 to that in 1998?
Offer a terse response. 0.64. What is the ratio of the Exports(as % of merchandise exports) in Macedonia in 1997 to that in 1998?
Your answer should be compact. 1.75. What is the ratio of the Exports(as % of merchandise exports) of Algeria in 1997 to that in 1999?
Offer a very short reply. 1.29. What is the ratio of the Exports(as % of merchandise exports) in Burkina Faso in 1997 to that in 1999?
Give a very brief answer. 0.94. What is the ratio of the Exports(as % of merchandise exports) in Egypt, Arab Rep. in 1997 to that in 1999?
Offer a terse response. 0.49. What is the ratio of the Exports(as % of merchandise exports) in Macedonia in 1997 to that in 1999?
Provide a succinct answer. 2.2. What is the ratio of the Exports(as % of merchandise exports) of Algeria in 1997 to that in 2000?
Offer a very short reply. 1. What is the ratio of the Exports(as % of merchandise exports) of Burkina Faso in 1997 to that in 2000?
Offer a terse response. 1.07. What is the ratio of the Exports(as % of merchandise exports) of Egypt, Arab Rep. in 1997 to that in 2000?
Offer a very short reply. 0.77. What is the ratio of the Exports(as % of merchandise exports) of Macedonia in 1997 to that in 2000?
Offer a terse response. 2.18. What is the ratio of the Exports(as % of merchandise exports) of Algeria in 1997 to that in 2001?
Make the answer very short. 0.91. What is the ratio of the Exports(as % of merchandise exports) of Burkina Faso in 1997 to that in 2001?
Your response must be concise. 1.05. What is the ratio of the Exports(as % of merchandise exports) in Egypt, Arab Rep. in 1997 to that in 2001?
Ensure brevity in your answer.  0.73. What is the ratio of the Exports(as % of merchandise exports) of Macedonia in 1997 to that in 2001?
Provide a succinct answer. 3.04. What is the ratio of the Exports(as % of merchandise exports) in Algeria in 1997 to that in 2002?
Keep it short and to the point. 3.18. What is the ratio of the Exports(as % of merchandise exports) in Burkina Faso in 1997 to that in 2002?
Ensure brevity in your answer.  1.03. What is the ratio of the Exports(as % of merchandise exports) of Egypt, Arab Rep. in 1997 to that in 2002?
Your answer should be very brief. 0.47. What is the ratio of the Exports(as % of merchandise exports) of Macedonia in 1997 to that in 2002?
Offer a terse response. 3.27. What is the ratio of the Exports(as % of merchandise exports) of Algeria in 1998 to that in 1999?
Provide a short and direct response. 2.85. What is the ratio of the Exports(as % of merchandise exports) of Burkina Faso in 1998 to that in 1999?
Give a very brief answer. 1.01. What is the ratio of the Exports(as % of merchandise exports) of Egypt, Arab Rep. in 1998 to that in 1999?
Your response must be concise. 0.76. What is the ratio of the Exports(as % of merchandise exports) in Macedonia in 1998 to that in 1999?
Provide a succinct answer. 1.26. What is the ratio of the Exports(as % of merchandise exports) of Algeria in 1998 to that in 2000?
Keep it short and to the point. 2.19. What is the ratio of the Exports(as % of merchandise exports) of Burkina Faso in 1998 to that in 2000?
Offer a very short reply. 1.15. What is the ratio of the Exports(as % of merchandise exports) of Egypt, Arab Rep. in 1998 to that in 2000?
Ensure brevity in your answer.  1.19. What is the ratio of the Exports(as % of merchandise exports) of Macedonia in 1998 to that in 2000?
Your answer should be compact. 1.25. What is the ratio of the Exports(as % of merchandise exports) of Algeria in 1998 to that in 2001?
Keep it short and to the point. 1.99. What is the ratio of the Exports(as % of merchandise exports) in Burkina Faso in 1998 to that in 2001?
Offer a very short reply. 1.13. What is the ratio of the Exports(as % of merchandise exports) of Egypt, Arab Rep. in 1998 to that in 2001?
Your answer should be very brief. 1.13. What is the ratio of the Exports(as % of merchandise exports) in Macedonia in 1998 to that in 2001?
Provide a short and direct response. 1.74. What is the ratio of the Exports(as % of merchandise exports) of Algeria in 1998 to that in 2002?
Ensure brevity in your answer.  7. What is the ratio of the Exports(as % of merchandise exports) of Burkina Faso in 1998 to that in 2002?
Make the answer very short. 1.1. What is the ratio of the Exports(as % of merchandise exports) in Egypt, Arab Rep. in 1998 to that in 2002?
Ensure brevity in your answer.  0.73. What is the ratio of the Exports(as % of merchandise exports) in Macedonia in 1998 to that in 2002?
Ensure brevity in your answer.  1.87. What is the ratio of the Exports(as % of merchandise exports) of Algeria in 1999 to that in 2000?
Provide a succinct answer. 0.77. What is the ratio of the Exports(as % of merchandise exports) in Burkina Faso in 1999 to that in 2000?
Your answer should be very brief. 1.14. What is the ratio of the Exports(as % of merchandise exports) in Egypt, Arab Rep. in 1999 to that in 2000?
Your answer should be compact. 1.57. What is the ratio of the Exports(as % of merchandise exports) of Algeria in 1999 to that in 2001?
Offer a very short reply. 0.7. What is the ratio of the Exports(as % of merchandise exports) in Burkina Faso in 1999 to that in 2001?
Your answer should be compact. 1.12. What is the ratio of the Exports(as % of merchandise exports) of Egypt, Arab Rep. in 1999 to that in 2001?
Ensure brevity in your answer.  1.49. What is the ratio of the Exports(as % of merchandise exports) of Macedonia in 1999 to that in 2001?
Give a very brief answer. 1.39. What is the ratio of the Exports(as % of merchandise exports) in Algeria in 1999 to that in 2002?
Your answer should be compact. 2.46. What is the ratio of the Exports(as % of merchandise exports) of Burkina Faso in 1999 to that in 2002?
Offer a terse response. 1.09. What is the ratio of the Exports(as % of merchandise exports) in Macedonia in 1999 to that in 2002?
Make the answer very short. 1.49. What is the ratio of the Exports(as % of merchandise exports) in Algeria in 2000 to that in 2001?
Offer a very short reply. 0.91. What is the ratio of the Exports(as % of merchandise exports) of Burkina Faso in 2000 to that in 2001?
Ensure brevity in your answer.  0.98. What is the ratio of the Exports(as % of merchandise exports) of Egypt, Arab Rep. in 2000 to that in 2001?
Your answer should be very brief. 0.95. What is the ratio of the Exports(as % of merchandise exports) in Macedonia in 2000 to that in 2001?
Provide a short and direct response. 1.39. What is the ratio of the Exports(as % of merchandise exports) in Algeria in 2000 to that in 2002?
Provide a short and direct response. 3.19. What is the ratio of the Exports(as % of merchandise exports) of Burkina Faso in 2000 to that in 2002?
Your answer should be compact. 0.96. What is the ratio of the Exports(as % of merchandise exports) in Egypt, Arab Rep. in 2000 to that in 2002?
Keep it short and to the point. 0.61. What is the ratio of the Exports(as % of merchandise exports) in Macedonia in 2000 to that in 2002?
Ensure brevity in your answer.  1.5. What is the ratio of the Exports(as % of merchandise exports) of Algeria in 2001 to that in 2002?
Your answer should be compact. 3.51. What is the ratio of the Exports(as % of merchandise exports) of Burkina Faso in 2001 to that in 2002?
Ensure brevity in your answer.  0.98. What is the ratio of the Exports(as % of merchandise exports) of Egypt, Arab Rep. in 2001 to that in 2002?
Your response must be concise. 0.65. What is the ratio of the Exports(as % of merchandise exports) of Macedonia in 2001 to that in 2002?
Ensure brevity in your answer.  1.07. What is the difference between the highest and the second highest Exports(as % of merchandise exports) in Algeria?
Your answer should be compact. 0.05. What is the difference between the highest and the second highest Exports(as % of merchandise exports) of Burkina Faso?
Give a very brief answer. 0.52. What is the difference between the highest and the second highest Exports(as % of merchandise exports) of Egypt, Arab Rep.?
Ensure brevity in your answer.  0.29. What is the difference between the highest and the second highest Exports(as % of merchandise exports) of Macedonia?
Ensure brevity in your answer.  1.59. What is the difference between the highest and the lowest Exports(as % of merchandise exports) in Algeria?
Make the answer very short. 0.09. What is the difference between the highest and the lowest Exports(as % of merchandise exports) of Burkina Faso?
Offer a very short reply. 8.98. What is the difference between the highest and the lowest Exports(as % of merchandise exports) of Egypt, Arab Rep.?
Provide a short and direct response. 4.31. What is the difference between the highest and the lowest Exports(as % of merchandise exports) of Macedonia?
Ensure brevity in your answer.  2.58. 